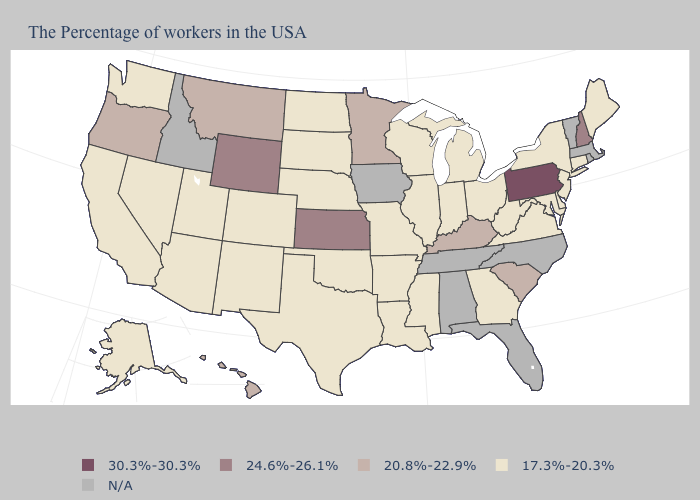Name the states that have a value in the range 20.8%-22.9%?
Keep it brief. South Carolina, Kentucky, Minnesota, Montana, Oregon, Hawaii. Name the states that have a value in the range 30.3%-30.3%?
Keep it brief. Pennsylvania. Is the legend a continuous bar?
Keep it brief. No. Which states have the lowest value in the USA?
Quick response, please. Maine, Connecticut, New York, New Jersey, Delaware, Maryland, Virginia, West Virginia, Ohio, Georgia, Michigan, Indiana, Wisconsin, Illinois, Mississippi, Louisiana, Missouri, Arkansas, Nebraska, Oklahoma, Texas, South Dakota, North Dakota, Colorado, New Mexico, Utah, Arizona, Nevada, California, Washington, Alaska. Name the states that have a value in the range 24.6%-26.1%?
Keep it brief. New Hampshire, Kansas, Wyoming. What is the value of Hawaii?
Write a very short answer. 20.8%-22.9%. Name the states that have a value in the range 24.6%-26.1%?
Be succinct. New Hampshire, Kansas, Wyoming. Name the states that have a value in the range N/A?
Give a very brief answer. Massachusetts, Rhode Island, Vermont, North Carolina, Florida, Alabama, Tennessee, Iowa, Idaho. Which states hav the highest value in the Northeast?
Give a very brief answer. Pennsylvania. Name the states that have a value in the range 17.3%-20.3%?
Answer briefly. Maine, Connecticut, New York, New Jersey, Delaware, Maryland, Virginia, West Virginia, Ohio, Georgia, Michigan, Indiana, Wisconsin, Illinois, Mississippi, Louisiana, Missouri, Arkansas, Nebraska, Oklahoma, Texas, South Dakota, North Dakota, Colorado, New Mexico, Utah, Arizona, Nevada, California, Washington, Alaska. What is the value of South Dakota?
Give a very brief answer. 17.3%-20.3%. Name the states that have a value in the range 24.6%-26.1%?
Quick response, please. New Hampshire, Kansas, Wyoming. Which states have the lowest value in the USA?
Quick response, please. Maine, Connecticut, New York, New Jersey, Delaware, Maryland, Virginia, West Virginia, Ohio, Georgia, Michigan, Indiana, Wisconsin, Illinois, Mississippi, Louisiana, Missouri, Arkansas, Nebraska, Oklahoma, Texas, South Dakota, North Dakota, Colorado, New Mexico, Utah, Arizona, Nevada, California, Washington, Alaska. 